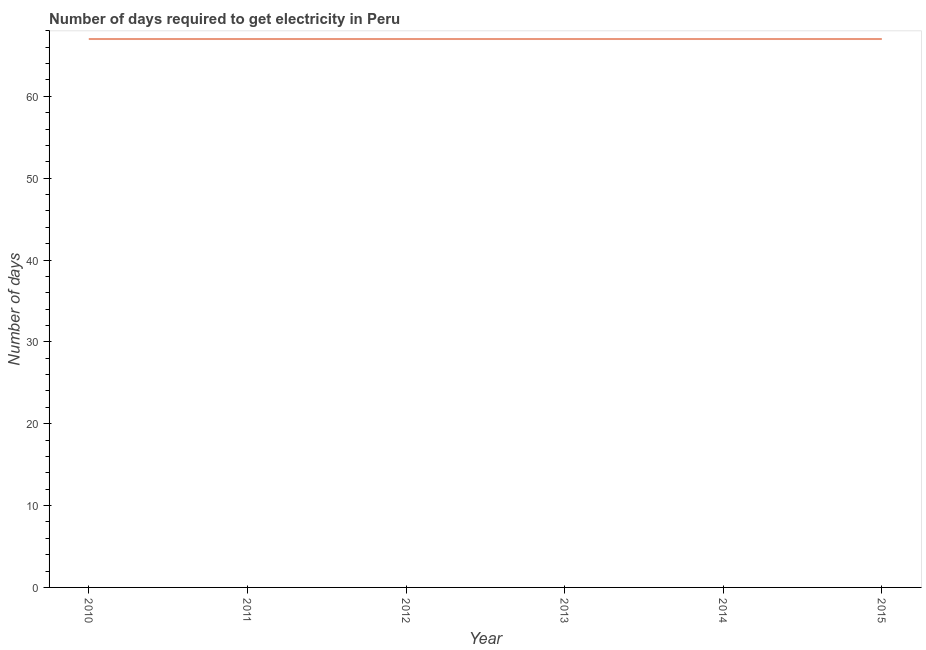What is the time to get electricity in 2012?
Provide a succinct answer. 67. Across all years, what is the maximum time to get electricity?
Your answer should be very brief. 67. Across all years, what is the minimum time to get electricity?
Your answer should be compact. 67. What is the sum of the time to get electricity?
Ensure brevity in your answer.  402. What is the median time to get electricity?
Your response must be concise. 67. In how many years, is the time to get electricity greater than 14 ?
Make the answer very short. 6. Do a majority of the years between 2011 and 2014 (inclusive) have time to get electricity greater than 38 ?
Keep it short and to the point. Yes. Is the difference between the time to get electricity in 2011 and 2014 greater than the difference between any two years?
Offer a terse response. Yes. What is the difference between the highest and the second highest time to get electricity?
Make the answer very short. 0. What is the difference between the highest and the lowest time to get electricity?
Offer a terse response. 0. Does the time to get electricity monotonically increase over the years?
Your answer should be compact. No. How many years are there in the graph?
Offer a terse response. 6. What is the difference between two consecutive major ticks on the Y-axis?
Offer a very short reply. 10. Does the graph contain any zero values?
Offer a terse response. No. Does the graph contain grids?
Give a very brief answer. No. What is the title of the graph?
Provide a succinct answer. Number of days required to get electricity in Peru. What is the label or title of the Y-axis?
Provide a short and direct response. Number of days. What is the Number of days of 2011?
Your answer should be very brief. 67. What is the Number of days of 2013?
Provide a short and direct response. 67. What is the Number of days in 2014?
Give a very brief answer. 67. What is the Number of days of 2015?
Make the answer very short. 67. What is the difference between the Number of days in 2010 and 2012?
Make the answer very short. 0. What is the difference between the Number of days in 2010 and 2014?
Keep it short and to the point. 0. What is the difference between the Number of days in 2010 and 2015?
Give a very brief answer. 0. What is the difference between the Number of days in 2011 and 2012?
Give a very brief answer. 0. What is the difference between the Number of days in 2012 and 2013?
Give a very brief answer. 0. What is the difference between the Number of days in 2012 and 2015?
Your answer should be very brief. 0. What is the difference between the Number of days in 2013 and 2014?
Offer a terse response. 0. What is the difference between the Number of days in 2013 and 2015?
Your answer should be compact. 0. What is the ratio of the Number of days in 2010 to that in 2011?
Offer a very short reply. 1. What is the ratio of the Number of days in 2010 to that in 2013?
Your answer should be very brief. 1. What is the ratio of the Number of days in 2010 to that in 2014?
Keep it short and to the point. 1. What is the ratio of the Number of days in 2011 to that in 2012?
Make the answer very short. 1. What is the ratio of the Number of days in 2011 to that in 2013?
Keep it short and to the point. 1. What is the ratio of the Number of days in 2011 to that in 2015?
Offer a terse response. 1. What is the ratio of the Number of days in 2012 to that in 2014?
Your answer should be very brief. 1. What is the ratio of the Number of days in 2013 to that in 2014?
Offer a terse response. 1. What is the ratio of the Number of days in 2014 to that in 2015?
Your response must be concise. 1. 